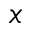<formula> <loc_0><loc_0><loc_500><loc_500>x</formula> 